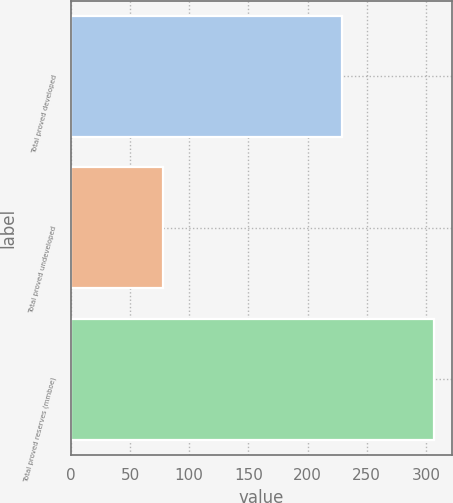Convert chart to OTSL. <chart><loc_0><loc_0><loc_500><loc_500><bar_chart><fcel>Total proved developed<fcel>Total proved undeveloped<fcel>Total proved reserves (mmboe)<nl><fcel>229<fcel>78<fcel>307<nl></chart> 